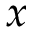<formula> <loc_0><loc_0><loc_500><loc_500>x</formula> 